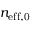Convert formula to latex. <formula><loc_0><loc_0><loc_500><loc_500>n _ { e f f , 0 }</formula> 